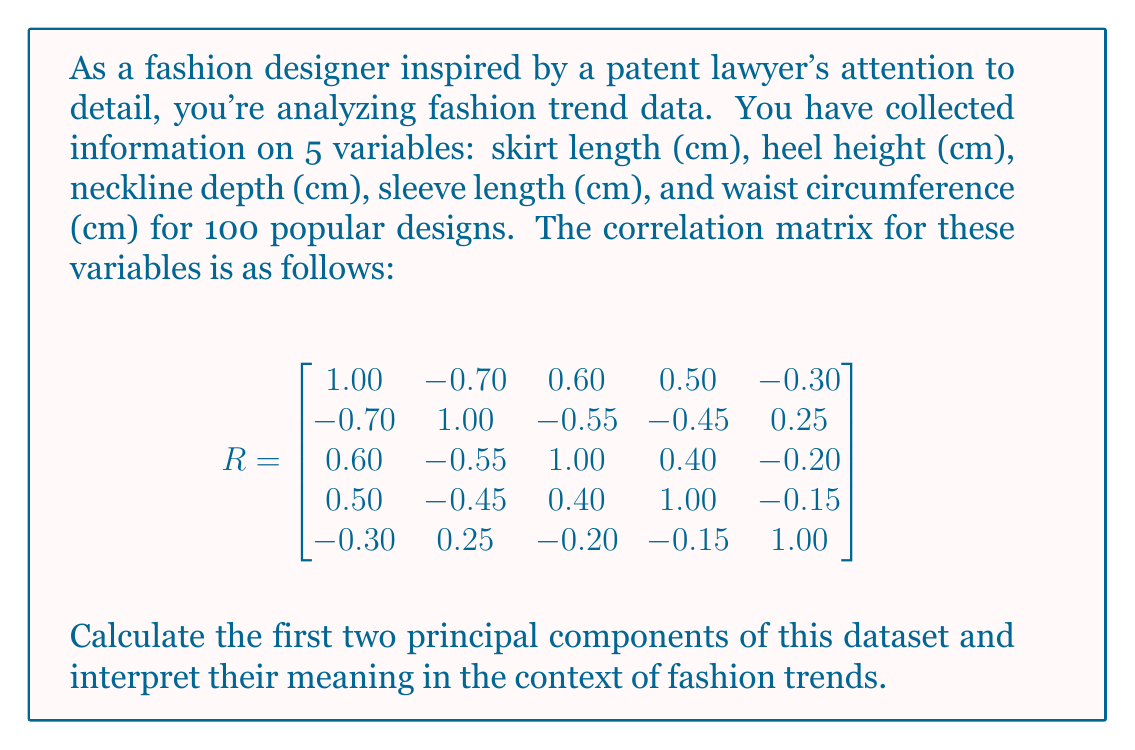Can you solve this math problem? To calculate the principal components, we need to follow these steps:

1. Find the eigenvalues and eigenvectors of the correlation matrix.
2. Sort the eigenvalues in descending order and select the corresponding eigenvectors.
3. Interpret the components based on the eigenvector coefficients.

Step 1: Calculate eigenvalues and eigenvectors

Using a statistical software or linear algebra calculator, we find the eigenvalues and eigenvectors of the correlation matrix R:

Eigenvalues:
$\lambda_1 = 2.8032$
$\lambda_2 = 1.0968$
$\lambda_3 = 0.5398$
$\lambda_4 = 0.3602$
$\lambda_5 = 0.2000$

Corresponding eigenvectors (normalized):
$$
\begin{align*}
v_1 &= [-0.5421, 0.5066, -0.4672, -0.4067, 0.2345] \\
v_2 &= [-0.1034, -0.1986, -0.1723, -0.1499, -0.9482] \\
v_3 &= [0.4067, 0.5421, 0.3602, 0.2345, -0.1986] \\
v_4 &= [-0.4672, -0.4067, 0.5066, 0.5421, -0.1034] \\
v_5 &= [0.5566, -0.5066, -0.5921, 0.6745, -0.0345]
\end{align*}
$$

Step 2: Select the first two principal components

The first two eigenvalues account for $(2.8032 + 1.0968) / 5 = 0.78$ or 78% of the total variance, which is sufficient for our analysis. We'll use the corresponding eigenvectors as our principal components:

PC1: $v_1 = [-0.5421, 0.5066, -0.4672, -0.4067, 0.2345]$
PC2: $v_2 = [-0.1034, -0.1986, -0.1723, -0.1499, -0.9482]$

Step 3: Interpret the components

PC1 interpretation:
- High negative loading for skirt length (-0.5421)
- High positive loading for heel height (0.5066)
- Moderate negative loadings for neckline depth (-0.4672) and sleeve length (-0.4067)
- Low positive loading for waist circumference (0.2345)

This component seems to represent a contrast between "revealing" and "conservative" styles. Higher values indicate shorter skirts, higher heels, deeper necklines, and shorter sleeves, while lower values indicate the opposite.

PC2 interpretation:
- Very high negative loading for waist circumference (-0.9482)
- Low to moderate negative loadings for other variables

This component primarily represents waist circumference, with some influence from other variables. Higher values indicate smaller waist circumferences and slightly more conservative styles overall.
Answer: The first two principal components are:

PC1: $[-0.5421, 0.5066, -0.4672, -0.4067, 0.2345]$
PC2: $[-0.1034, -0.1986, -0.1723, -0.1499, -0.9482]$

Interpretation:
PC1 represents a spectrum from revealing to conservative styles, accounting for 56.06% of the variance.
PC2 primarily represents waist circumference with some influence on overall style, accounting for 21.94% of the variance. 